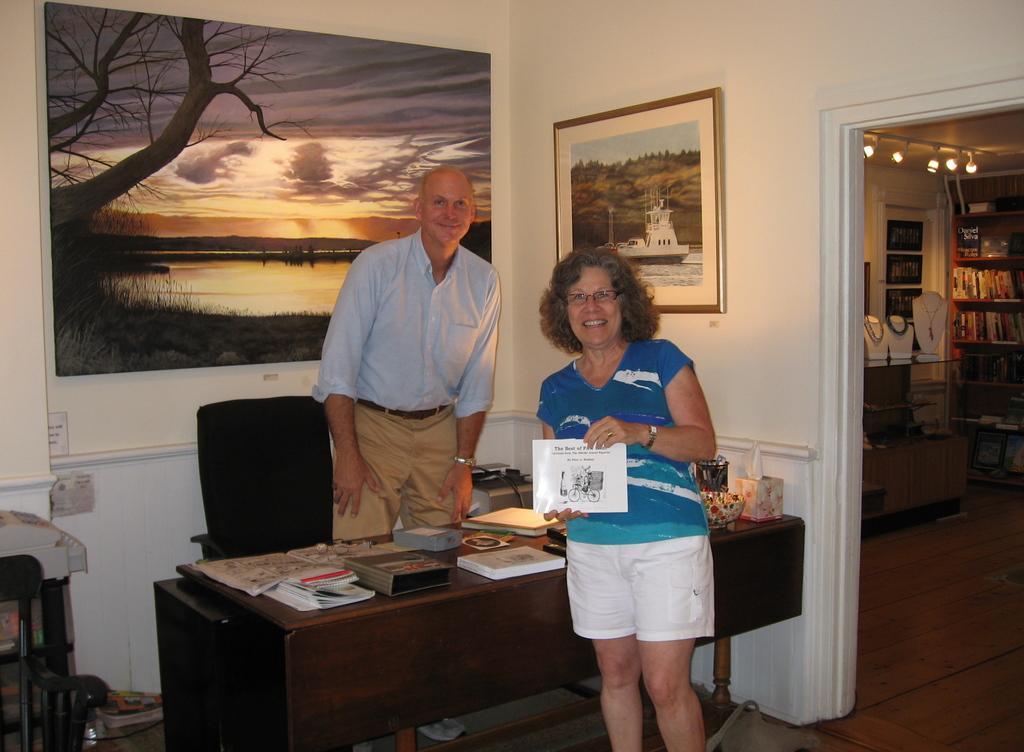In one or two sentences, can you explain what this image depicts? In the image we can see there are people who are standing on the floor and in front of them there is a table on which there are books. At the back on the wall there is a poster and on the other side there is a book shelf in which books are kept. 